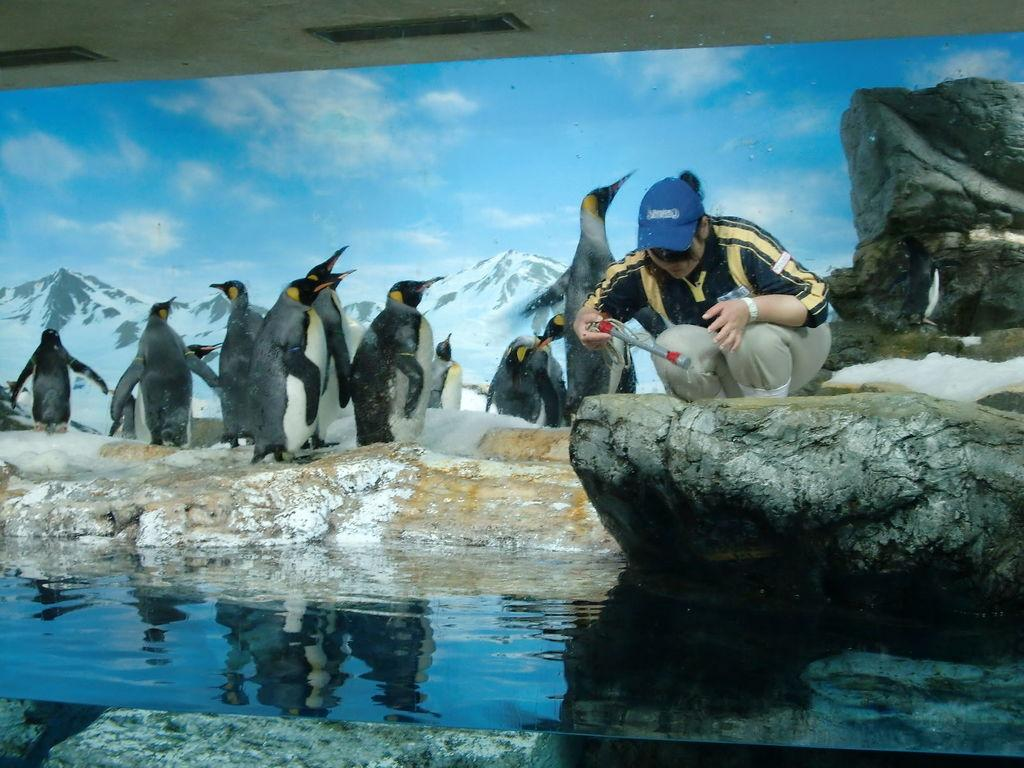What is located in the center of the image? There is water in the center of the image. What is the woman standing on in the image? The woman is standing on a stone in the image. What type of animals can be seen in the background of the image? There are penguins in the background of the image. What type of natural formation is visible in the background of the image? There are mountains in the background of the image. How would you describe the sky in the image? The sky is cloudy in the image. What type of dress is the woman wearing in the image? There is no information about the woman's dress in the image. Can you see the moon in the image? The moon is not visible in the image; only the cloudy sky is present. 